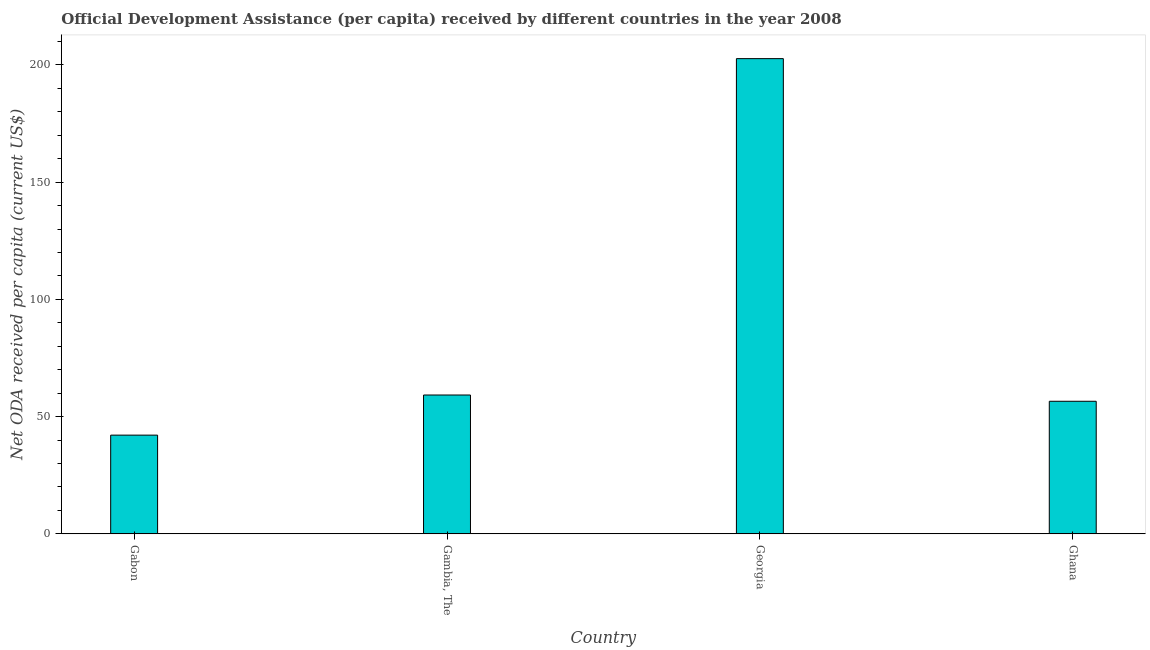Does the graph contain any zero values?
Ensure brevity in your answer.  No. Does the graph contain grids?
Give a very brief answer. No. What is the title of the graph?
Make the answer very short. Official Development Assistance (per capita) received by different countries in the year 2008. What is the label or title of the Y-axis?
Offer a very short reply. Net ODA received per capita (current US$). What is the net oda received per capita in Gambia, The?
Your response must be concise. 59.21. Across all countries, what is the maximum net oda received per capita?
Keep it short and to the point. 202.65. Across all countries, what is the minimum net oda received per capita?
Give a very brief answer. 42.1. In which country was the net oda received per capita maximum?
Ensure brevity in your answer.  Georgia. In which country was the net oda received per capita minimum?
Offer a very short reply. Gabon. What is the sum of the net oda received per capita?
Your response must be concise. 360.5. What is the difference between the net oda received per capita in Gabon and Gambia, The?
Make the answer very short. -17.11. What is the average net oda received per capita per country?
Provide a short and direct response. 90.13. What is the median net oda received per capita?
Offer a very short reply. 57.87. In how many countries, is the net oda received per capita greater than 60 US$?
Make the answer very short. 1. What is the ratio of the net oda received per capita in Gambia, The to that in Georgia?
Your answer should be very brief. 0.29. Is the net oda received per capita in Gabon less than that in Gambia, The?
Keep it short and to the point. Yes. Is the difference between the net oda received per capita in Gabon and Georgia greater than the difference between any two countries?
Provide a succinct answer. Yes. What is the difference between the highest and the second highest net oda received per capita?
Provide a succinct answer. 143.44. What is the difference between the highest and the lowest net oda received per capita?
Make the answer very short. 160.55. Are all the bars in the graph horizontal?
Provide a succinct answer. No. How many countries are there in the graph?
Your response must be concise. 4. What is the difference between two consecutive major ticks on the Y-axis?
Give a very brief answer. 50. Are the values on the major ticks of Y-axis written in scientific E-notation?
Your answer should be compact. No. What is the Net ODA received per capita (current US$) in Gabon?
Your response must be concise. 42.1. What is the Net ODA received per capita (current US$) in Gambia, The?
Your response must be concise. 59.21. What is the Net ODA received per capita (current US$) of Georgia?
Make the answer very short. 202.65. What is the Net ODA received per capita (current US$) in Ghana?
Your response must be concise. 56.54. What is the difference between the Net ODA received per capita (current US$) in Gabon and Gambia, The?
Give a very brief answer. -17.11. What is the difference between the Net ODA received per capita (current US$) in Gabon and Georgia?
Make the answer very short. -160.55. What is the difference between the Net ODA received per capita (current US$) in Gabon and Ghana?
Your response must be concise. -14.43. What is the difference between the Net ODA received per capita (current US$) in Gambia, The and Georgia?
Ensure brevity in your answer.  -143.44. What is the difference between the Net ODA received per capita (current US$) in Gambia, The and Ghana?
Your response must be concise. 2.67. What is the difference between the Net ODA received per capita (current US$) in Georgia and Ghana?
Offer a terse response. 146.11. What is the ratio of the Net ODA received per capita (current US$) in Gabon to that in Gambia, The?
Make the answer very short. 0.71. What is the ratio of the Net ODA received per capita (current US$) in Gabon to that in Georgia?
Give a very brief answer. 0.21. What is the ratio of the Net ODA received per capita (current US$) in Gabon to that in Ghana?
Your response must be concise. 0.74. What is the ratio of the Net ODA received per capita (current US$) in Gambia, The to that in Georgia?
Provide a short and direct response. 0.29. What is the ratio of the Net ODA received per capita (current US$) in Gambia, The to that in Ghana?
Provide a short and direct response. 1.05. What is the ratio of the Net ODA received per capita (current US$) in Georgia to that in Ghana?
Keep it short and to the point. 3.58. 